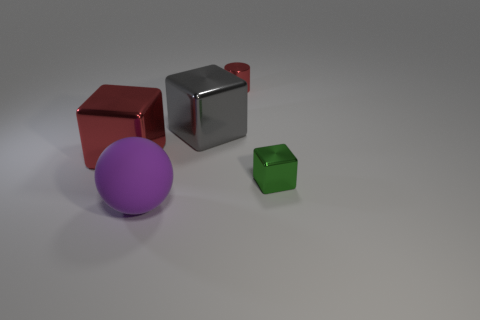Add 2 red cubes. How many objects exist? 7 Subtract all cylinders. How many objects are left? 4 Add 5 tiny metallic cylinders. How many tiny metallic cylinders are left? 6 Add 3 metal cylinders. How many metal cylinders exist? 4 Subtract 0 purple cylinders. How many objects are left? 5 Subtract all big purple metallic cylinders. Subtract all small red metal cylinders. How many objects are left? 4 